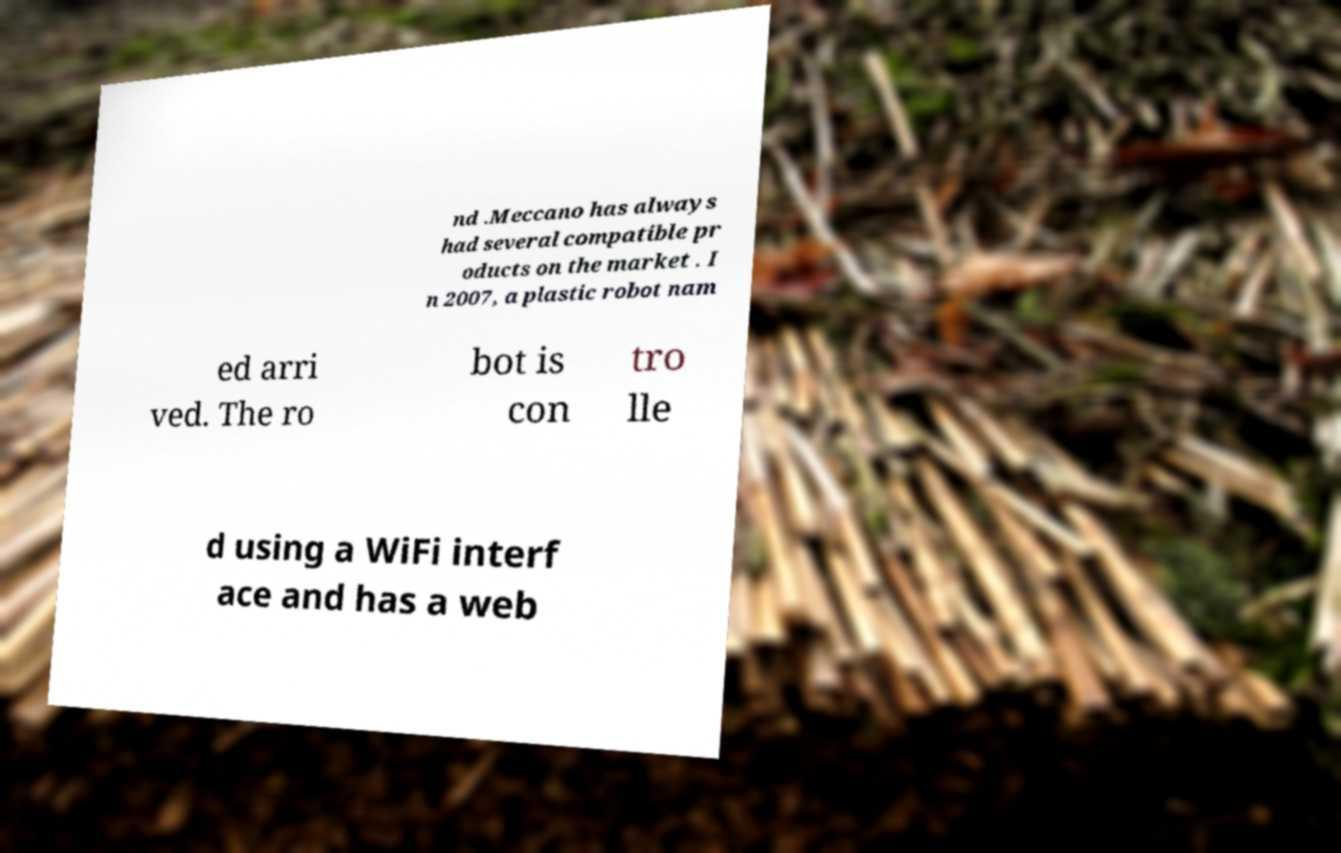Can you accurately transcribe the text from the provided image for me? nd .Meccano has always had several compatible pr oducts on the market . I n 2007, a plastic robot nam ed arri ved. The ro bot is con tro lle d using a WiFi interf ace and has a web 